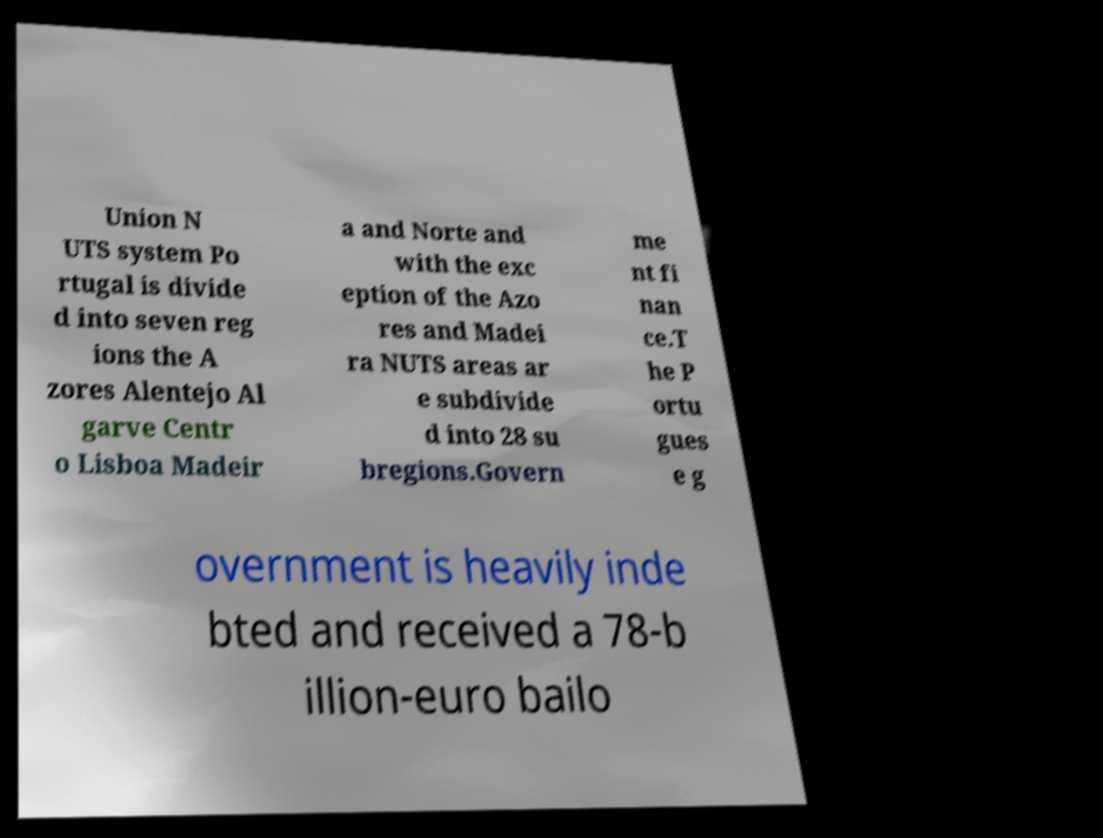Could you extract and type out the text from this image? Union N UTS system Po rtugal is divide d into seven reg ions the A zores Alentejo Al garve Centr o Lisboa Madeir a and Norte and with the exc eption of the Azo res and Madei ra NUTS areas ar e subdivide d into 28 su bregions.Govern me nt fi nan ce.T he P ortu gues e g overnment is heavily inde bted and received a 78-b illion-euro bailo 